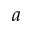<formula> <loc_0><loc_0><loc_500><loc_500>a</formula> 